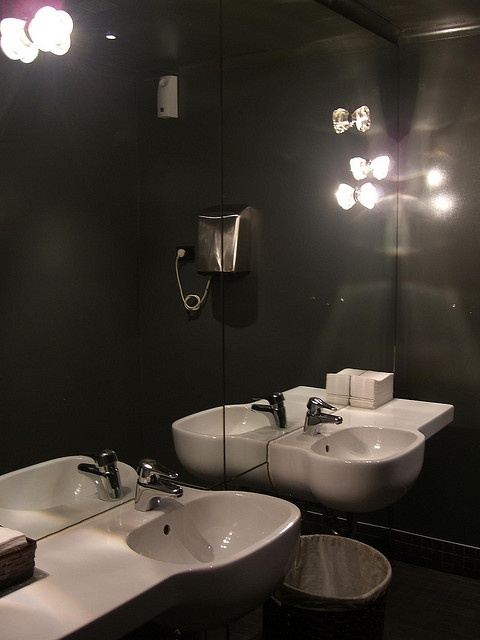Describe the objects in this image and their specific colors. I can see sink in purple, gray, and darkgray tones, sink in purple, gray, and darkgray tones, sink in purple, darkgray, gray, and tan tones, and sink in purple, gray, and darkgray tones in this image. 